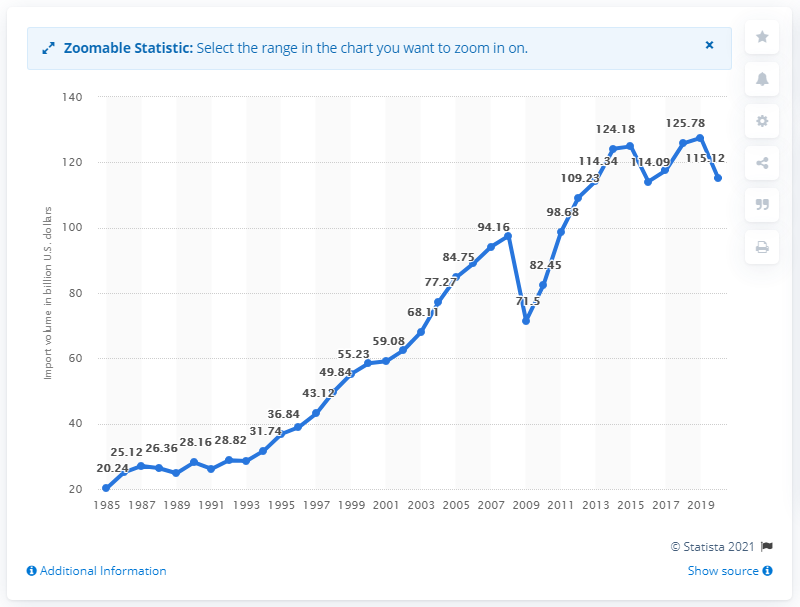List a handful of essential elements in this visual. In 2020, the value of U.S. imports from Germany was 115.12 billion dollars. 